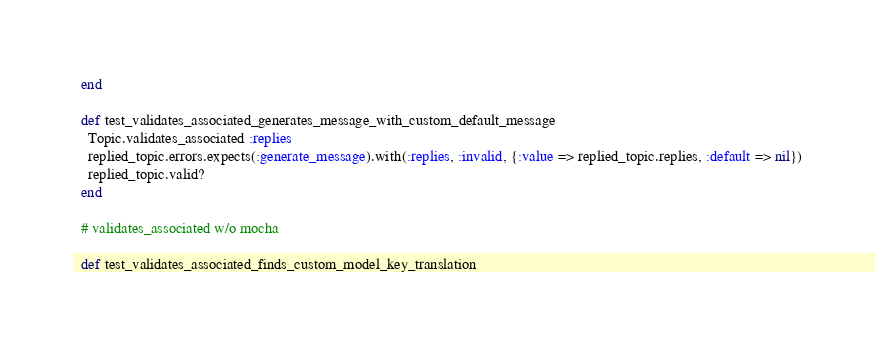Convert code to text. <code><loc_0><loc_0><loc_500><loc_500><_Ruby_>  end

  def test_validates_associated_generates_message_with_custom_default_message
    Topic.validates_associated :replies
    replied_topic.errors.expects(:generate_message).with(:replies, :invalid, {:value => replied_topic.replies, :default => nil})
    replied_topic.valid?
  end

  # validates_associated w/o mocha

  def test_validates_associated_finds_custom_model_key_translation</code> 